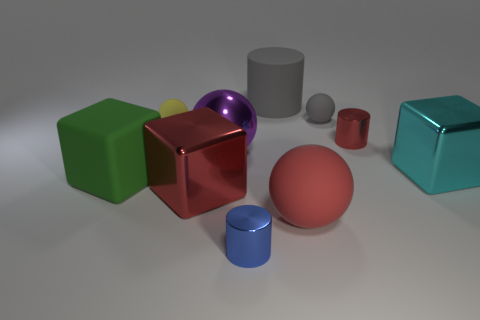What is the texture of the objects? From the image, it seems that each object has a distinct texture. The green, purple, and teal objects look like they have a shiny, smooth surface, while the red cube reflects light like a polished metallic surface. The grey cylinder and smaller sphere have a matte finish, indicative of a rubber-like material. 